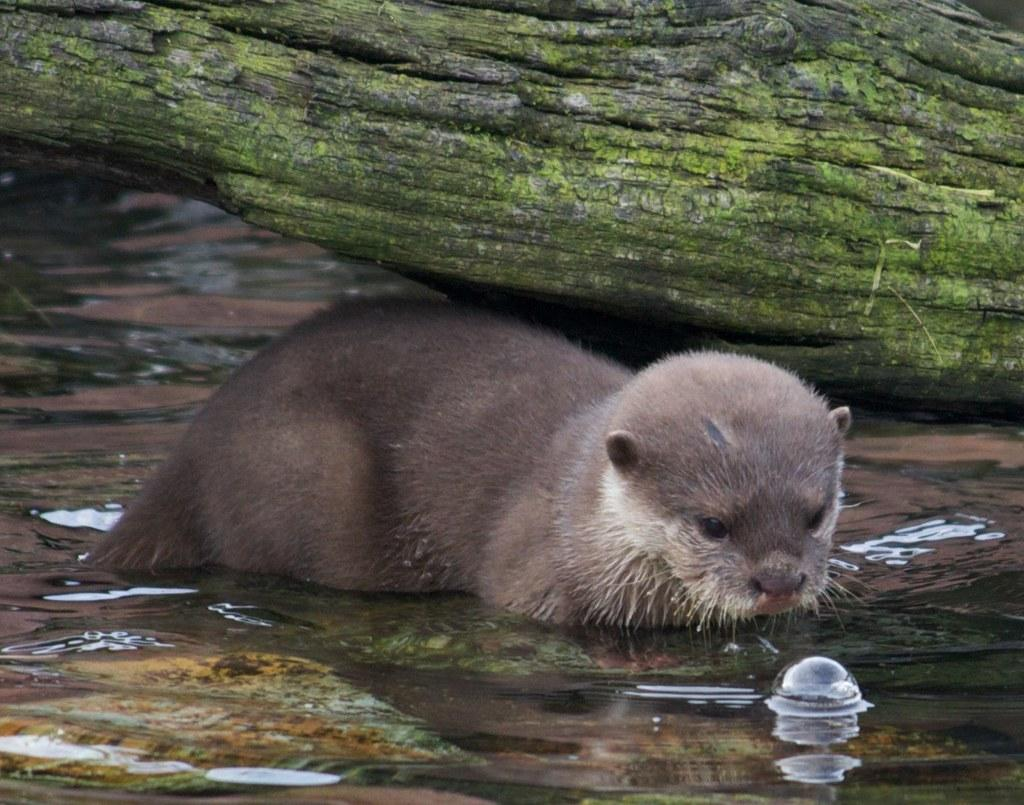What animal is present in the image? There is an otter in the image. What type of environment is depicted in the image? There is water visible towards the bottom of the image. What is the otter doing in the image? The otter is likely swimming or playing in the water. What can be seen near the top of the image? There is a tree trunk towards the top of the image. How is the otter helping with the destruction of the popcorn in the image? There is no popcorn present in the image, and the otter is not involved in any destruction. 